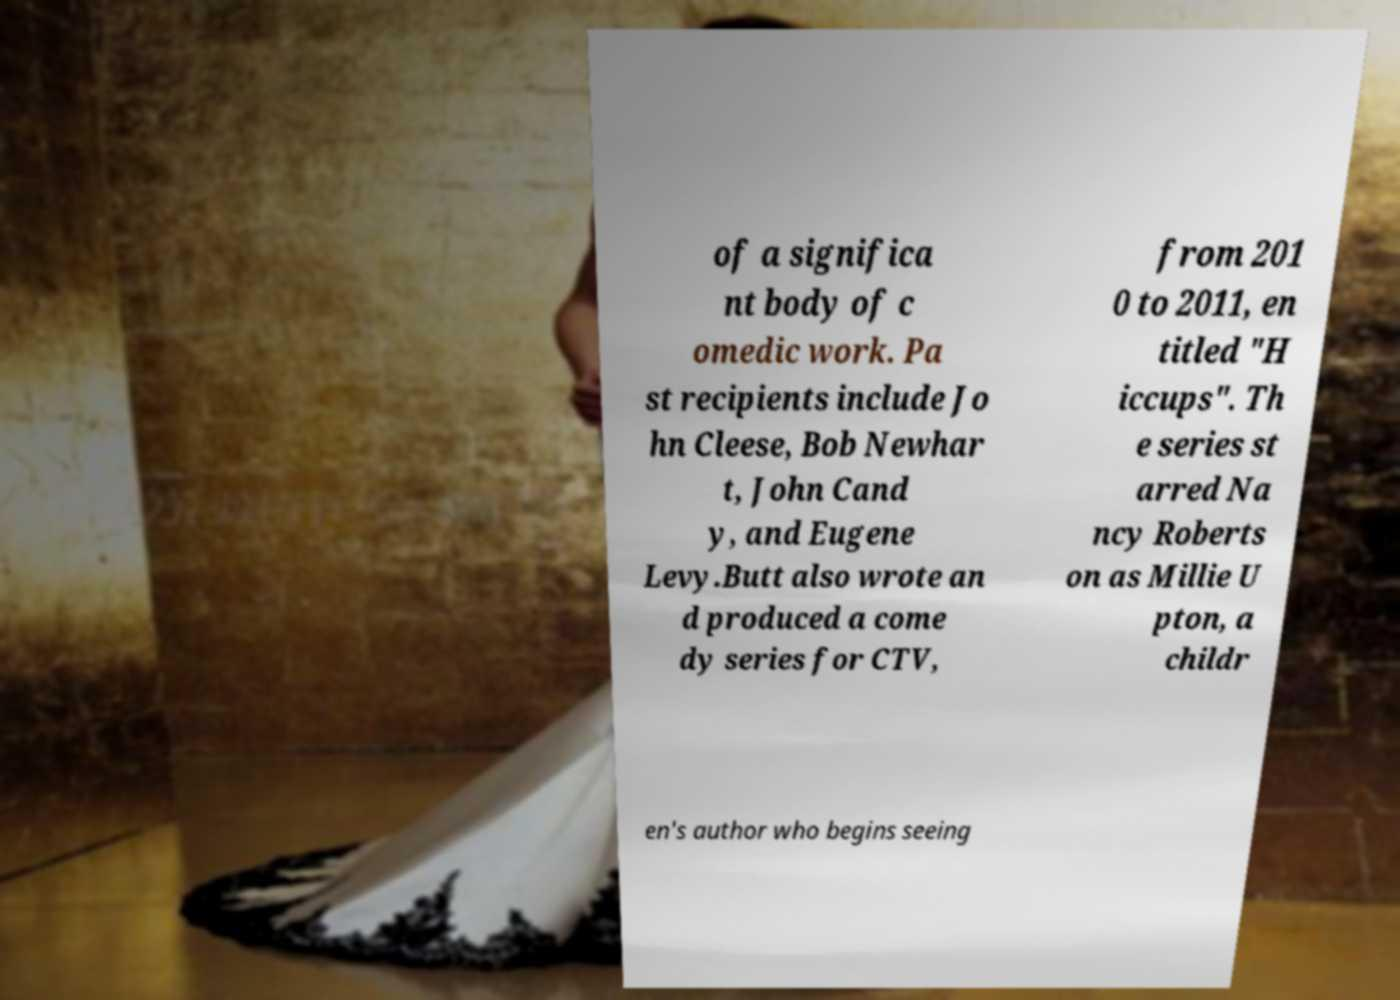Can you read and provide the text displayed in the image?This photo seems to have some interesting text. Can you extract and type it out for me? of a significa nt body of c omedic work. Pa st recipients include Jo hn Cleese, Bob Newhar t, John Cand y, and Eugene Levy.Butt also wrote an d produced a come dy series for CTV, from 201 0 to 2011, en titled "H iccups". Th e series st arred Na ncy Roberts on as Millie U pton, a childr en's author who begins seeing 